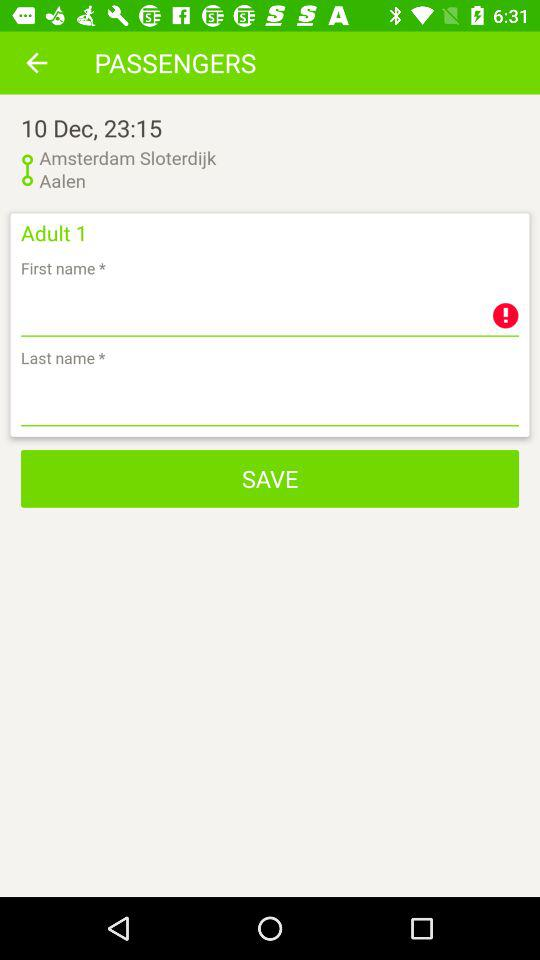What is the date? The date is December 10. 